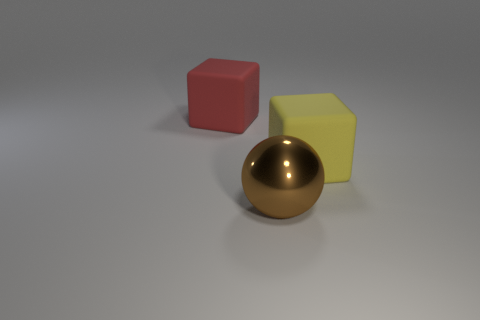Add 1 small purple rubber cylinders. How many objects exist? 4 Add 2 large things. How many large things exist? 5 Subtract 0 brown cylinders. How many objects are left? 3 Subtract all cubes. How many objects are left? 1 Subtract all tiny red rubber cylinders. Subtract all yellow blocks. How many objects are left? 2 Add 1 brown objects. How many brown objects are left? 2 